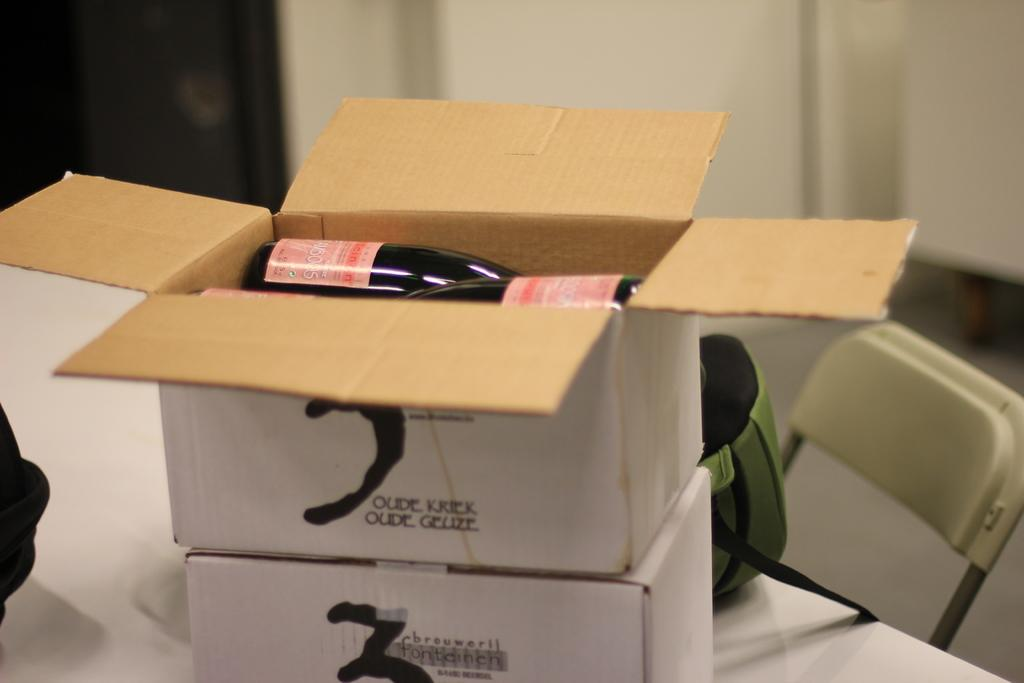<image>
Write a terse but informative summary of the picture. Two white boxes with the words Oude Kriek Oude Geuze on top of one another. 